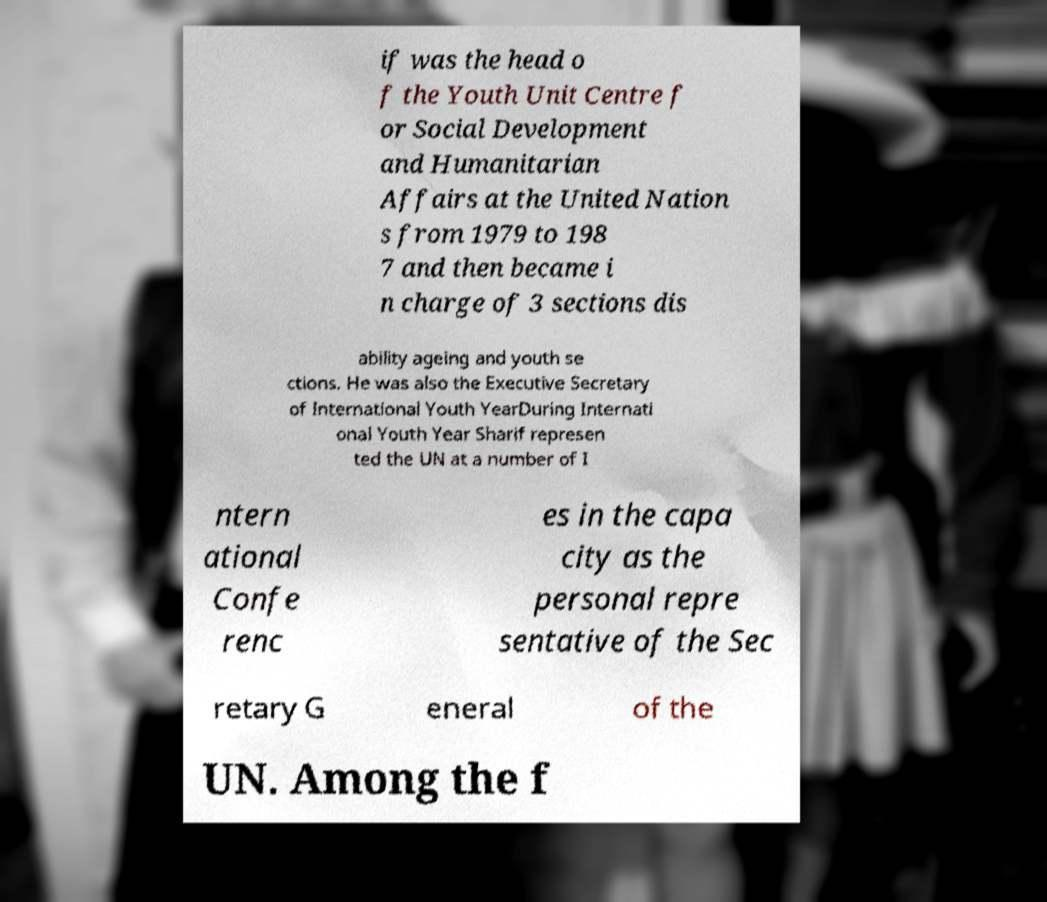There's text embedded in this image that I need extracted. Can you transcribe it verbatim? if was the head o f the Youth Unit Centre f or Social Development and Humanitarian Affairs at the United Nation s from 1979 to 198 7 and then became i n charge of 3 sections dis ability ageing and youth se ctions. He was also the Executive Secretary of International Youth YearDuring Internati onal Youth Year Sharif represen ted the UN at a number of I ntern ational Confe renc es in the capa city as the personal repre sentative of the Sec retary G eneral of the UN. Among the f 